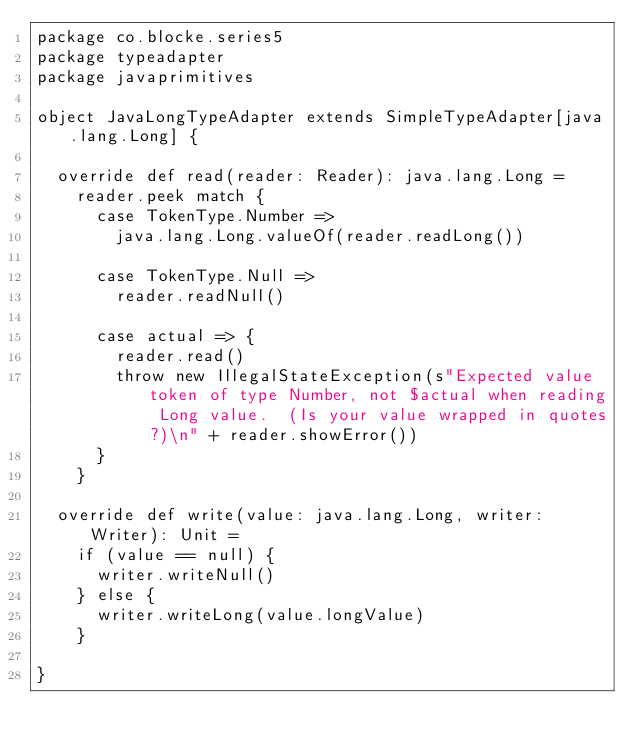Convert code to text. <code><loc_0><loc_0><loc_500><loc_500><_Scala_>package co.blocke.series5
package typeadapter
package javaprimitives

object JavaLongTypeAdapter extends SimpleTypeAdapter[java.lang.Long] {

  override def read(reader: Reader): java.lang.Long =
    reader.peek match {
      case TokenType.Number =>
        java.lang.Long.valueOf(reader.readLong())

      case TokenType.Null =>
        reader.readNull()

      case actual => {
        reader.read()
        throw new IllegalStateException(s"Expected value token of type Number, not $actual when reading Long value.  (Is your value wrapped in quotes?)\n" + reader.showError())
      }
    }

  override def write(value: java.lang.Long, writer: Writer): Unit =
    if (value == null) {
      writer.writeNull()
    } else {
      writer.writeLong(value.longValue)
    }

}
</code> 